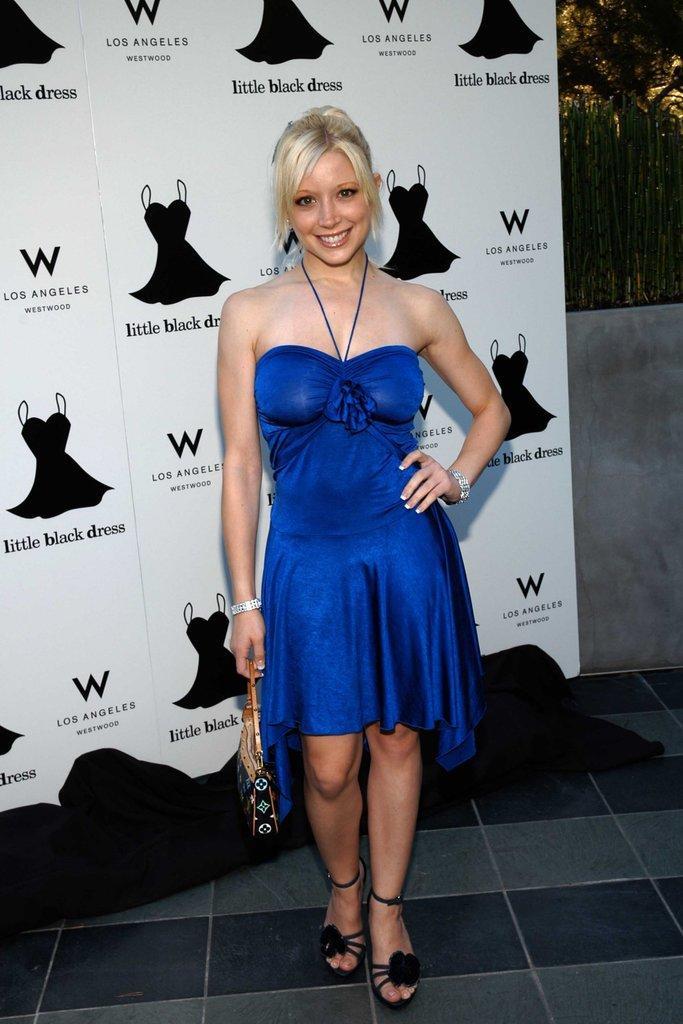In one or two sentences, can you explain what this image depicts? In the middle of this image, there is a woman in a violet color dress, holding a handbag with a hand and smiling. In the background, there is a banner, on which there are paintings of black color dresses and black color texts and there are trees. 